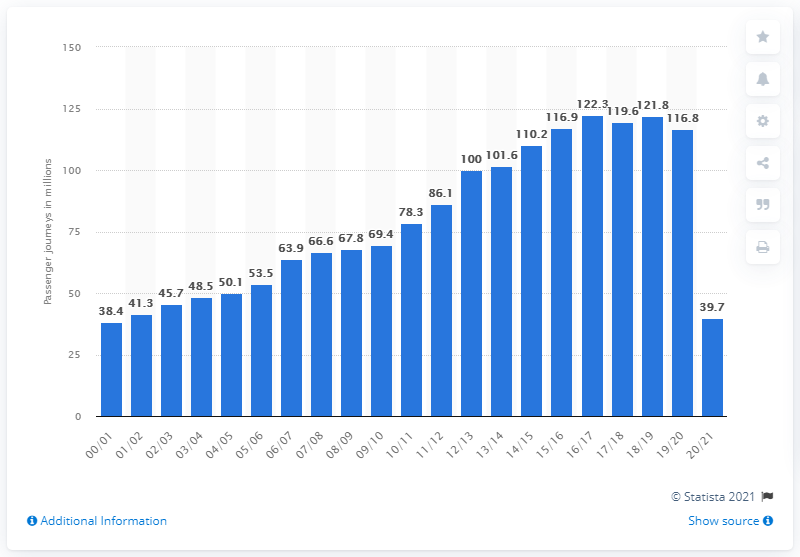Give some essential details in this illustration. In the year 2020/2021, 39,700 passenger journeys were made using the light rail system. In 2000/01, a total of 38.4 passenger journeys were made with the Docklands Light Railway. In the year 2016/17, a total of 121,800 passenger journeys were made using the Docklands Light Railway. 